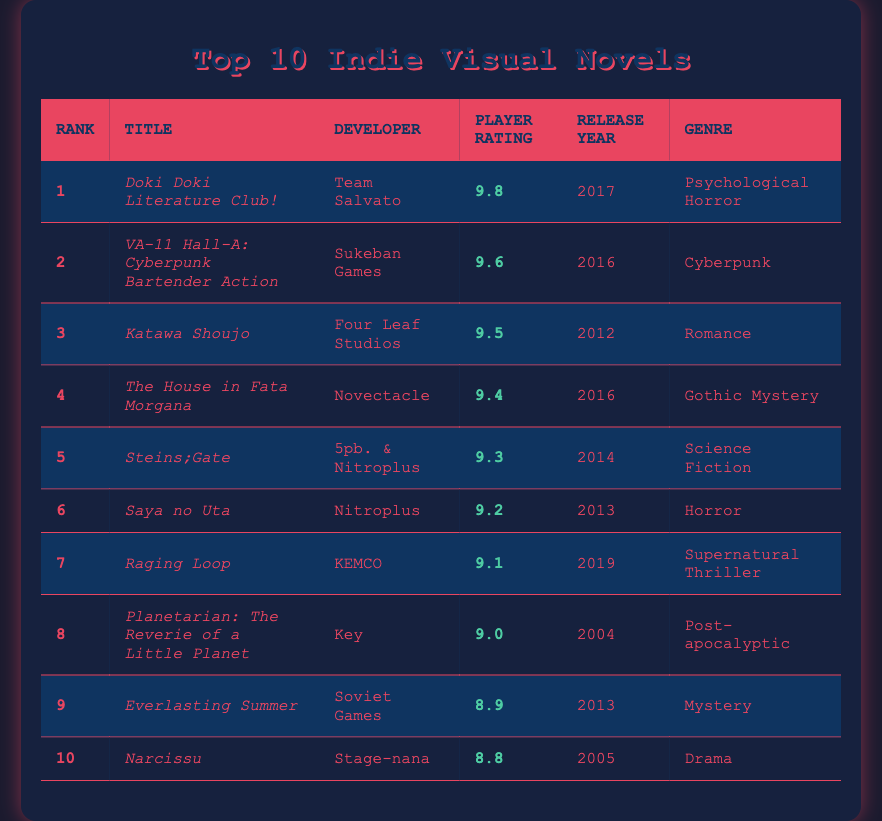What is the title of the highest-rated indie visual novel? The highest-rated visual novel is in the first row of the table, which shows that "Doki Doki Literature Club!" has the highest player rating of 9.8 as per its ranking.
Answer: Doki Doki Literature Club! Which developer created "Katawa Shoujo"? The title "Katawa Shoujo" is listed in the third row of the table, and the developer name in that row is "Four Leaf Studios."
Answer: Four Leaf Studios What is the average player rating of the top 5 indie visual novels? To find the average, first sum the ratings: 9.8 + 9.6 + 9.5 + 9.4 + 9.3 = 47.6. There are 5 titles, so the average rating is 47.6/5 = 9.52.
Answer: 9.52 Is "Narcissu" a horror genre game? Looking at the genre column for "Narcissu," which is in the tenth position, it lists "Drama," indicating it is not a horror game.
Answer: No How many indie visual novels were released after 2015? By examining the release years in the table, the titles released after 2015 are "Raging Loop" (2019), "Doki Doki Literature Club!" (2017), "VA-11 Hall-A" (2016), and "The House in Fata Morgana" (2016). That's a total of 4 titles.
Answer: 4 